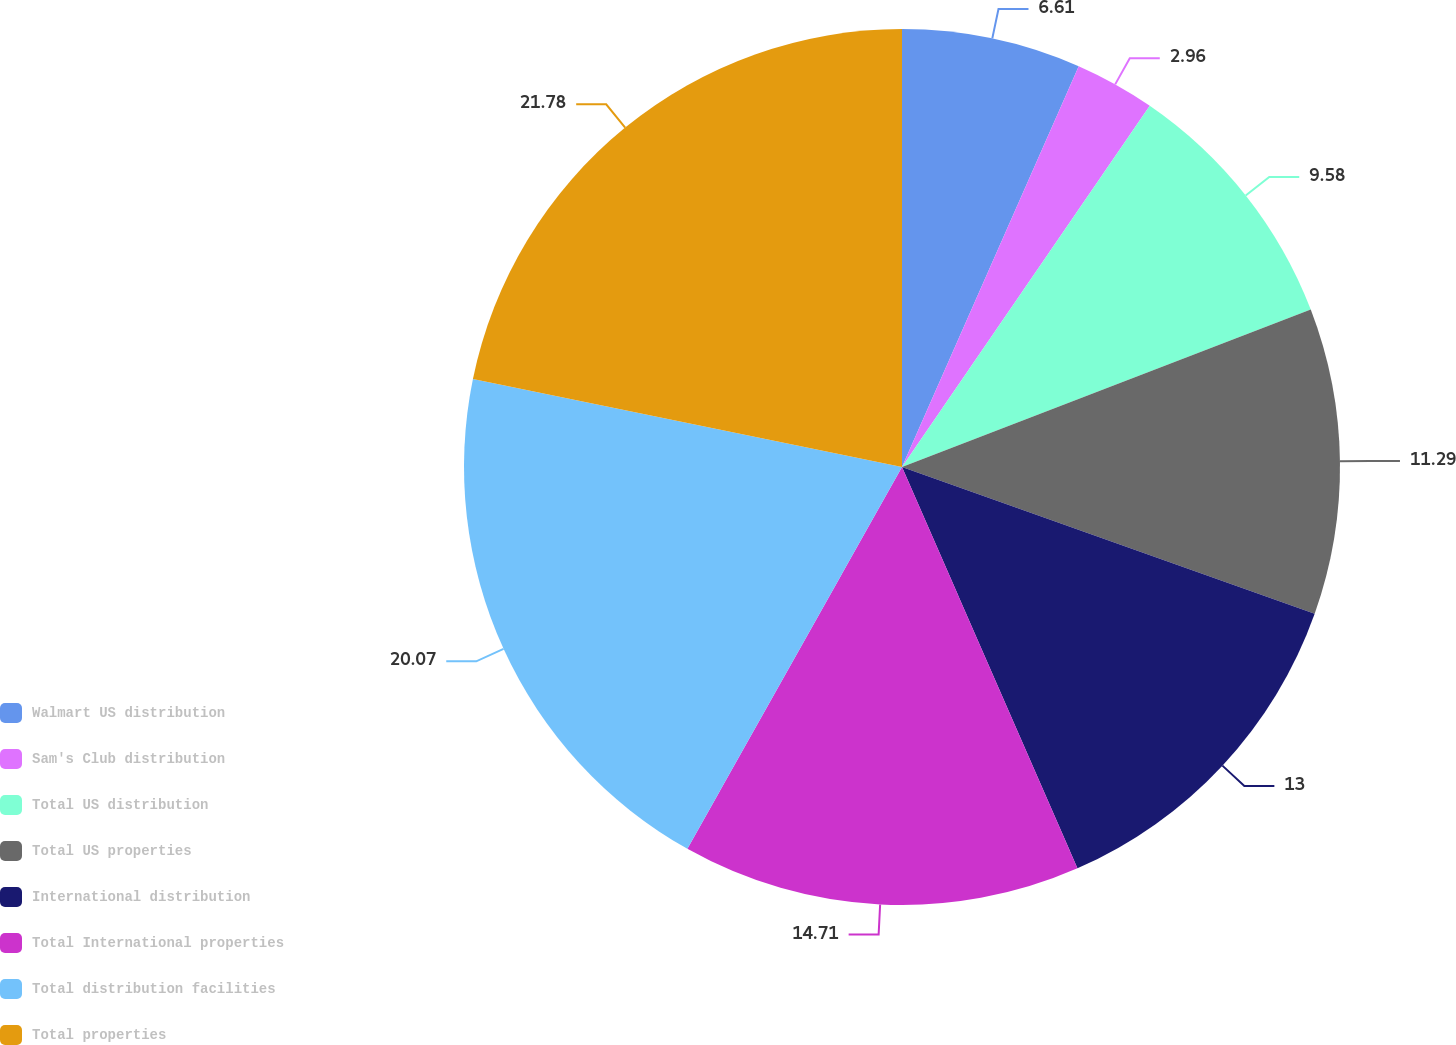Convert chart to OTSL. <chart><loc_0><loc_0><loc_500><loc_500><pie_chart><fcel>Walmart US distribution<fcel>Sam's Club distribution<fcel>Total US distribution<fcel>Total US properties<fcel>International distribution<fcel>Total International properties<fcel>Total distribution facilities<fcel>Total properties<nl><fcel>6.61%<fcel>2.96%<fcel>9.58%<fcel>11.29%<fcel>13.0%<fcel>14.71%<fcel>20.07%<fcel>21.78%<nl></chart> 